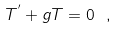<formula> <loc_0><loc_0><loc_500><loc_500>\label l { e q \colon T e e 2 } T ^ { ^ { \prime } } + g T = 0 \ ,</formula> 